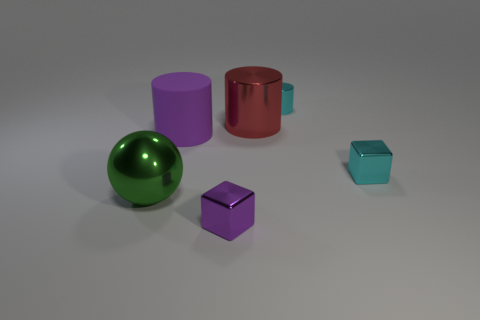Add 1 red metal cylinders. How many objects exist? 7 Subtract all blocks. How many objects are left? 4 Add 1 large metal objects. How many large metal objects are left? 3 Add 4 brown matte cylinders. How many brown matte cylinders exist? 4 Subtract 0 red blocks. How many objects are left? 6 Subtract all balls. Subtract all purple metal things. How many objects are left? 4 